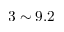Convert formula to latex. <formula><loc_0><loc_0><loc_500><loc_500>3 \sim 9 . 2</formula> 